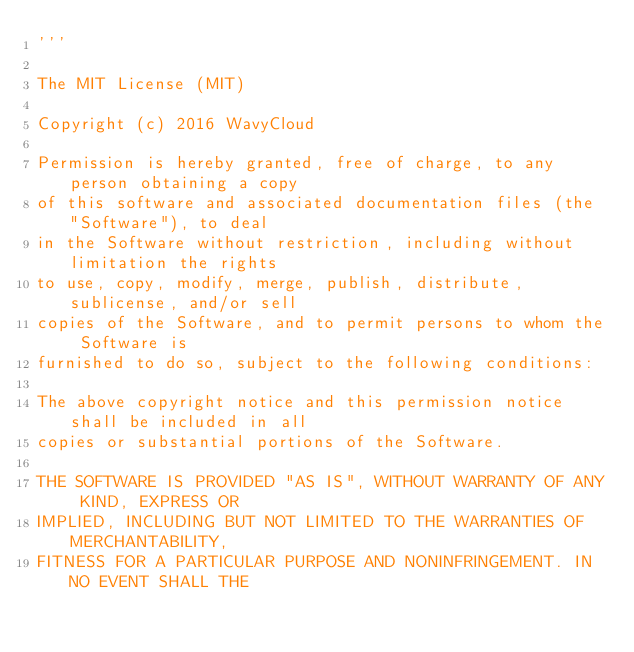Convert code to text. <code><loc_0><loc_0><loc_500><loc_500><_Python_>'''

The MIT License (MIT)

Copyright (c) 2016 WavyCloud

Permission is hereby granted, free of charge, to any person obtaining a copy
of this software and associated documentation files (the "Software"), to deal
in the Software without restriction, including without limitation the rights
to use, copy, modify, merge, publish, distribute, sublicense, and/or sell
copies of the Software, and to permit persons to whom the Software is
furnished to do so, subject to the following conditions:

The above copyright notice and this permission notice shall be included in all
copies or substantial portions of the Software.

THE SOFTWARE IS PROVIDED "AS IS", WITHOUT WARRANTY OF ANY KIND, EXPRESS OR
IMPLIED, INCLUDING BUT NOT LIMITED TO THE WARRANTIES OF MERCHANTABILITY,
FITNESS FOR A PARTICULAR PURPOSE AND NONINFRINGEMENT. IN NO EVENT SHALL THE</code> 